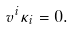Convert formula to latex. <formula><loc_0><loc_0><loc_500><loc_500>v ^ { i } \kappa _ { i } = 0 .</formula> 